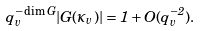<formula> <loc_0><loc_0><loc_500><loc_500>q _ { v } ^ { - \dim G } | G ( \kappa _ { v } ) | = 1 + O ( q _ { v } ^ { - 2 } ) .</formula> 